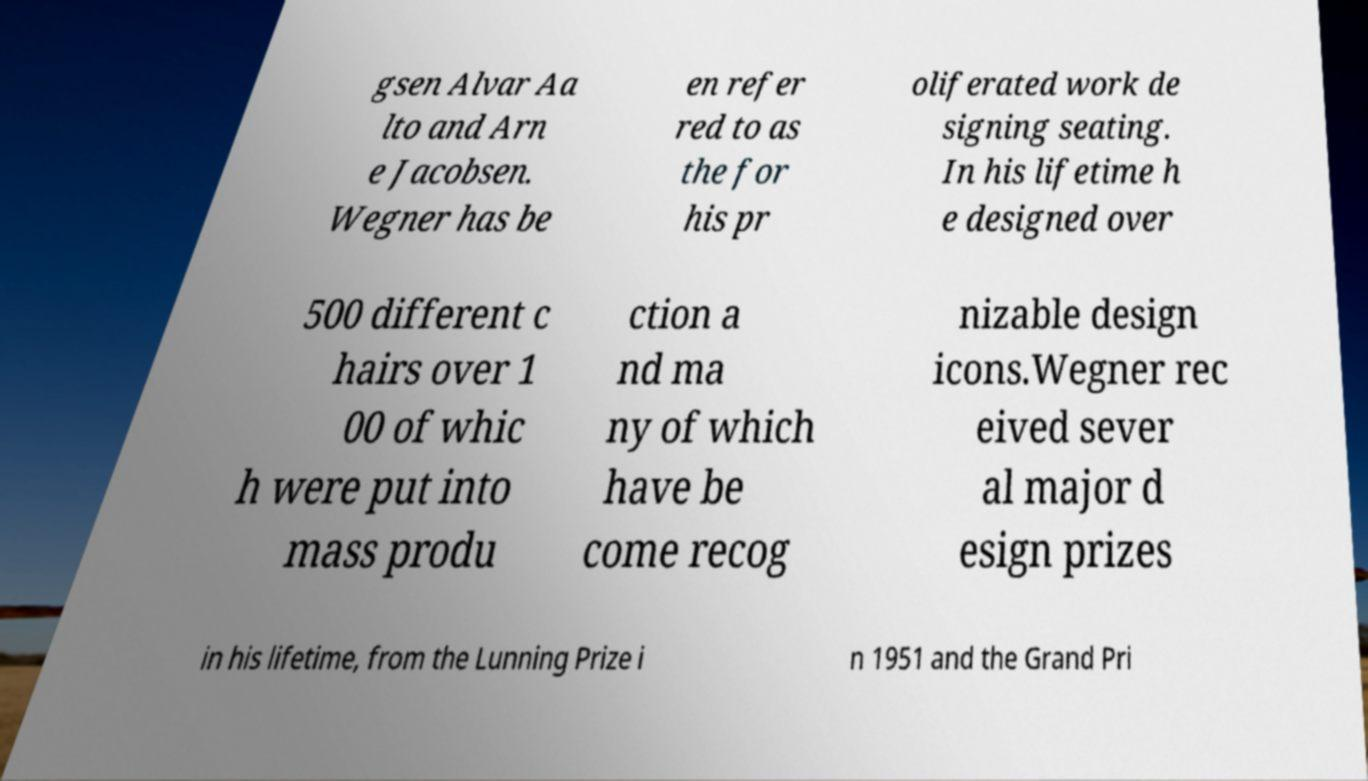Could you extract and type out the text from this image? gsen Alvar Aa lto and Arn e Jacobsen. Wegner has be en refer red to as the for his pr oliferated work de signing seating. In his lifetime h e designed over 500 different c hairs over 1 00 of whic h were put into mass produ ction a nd ma ny of which have be come recog nizable design icons.Wegner rec eived sever al major d esign prizes in his lifetime, from the Lunning Prize i n 1951 and the Grand Pri 